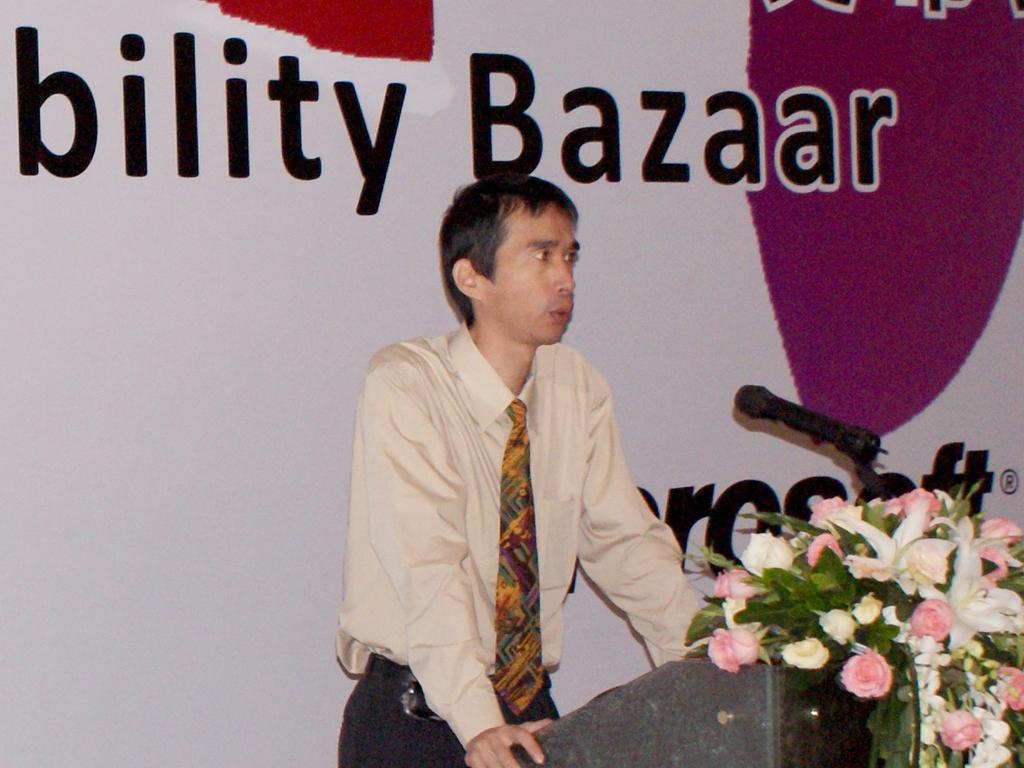Could you give a brief overview of what you see in this image? In the foreground of this image, there is a man standing near a podium on which few flowers are placed and there is also a mic. In the background, there is a banner wall. 